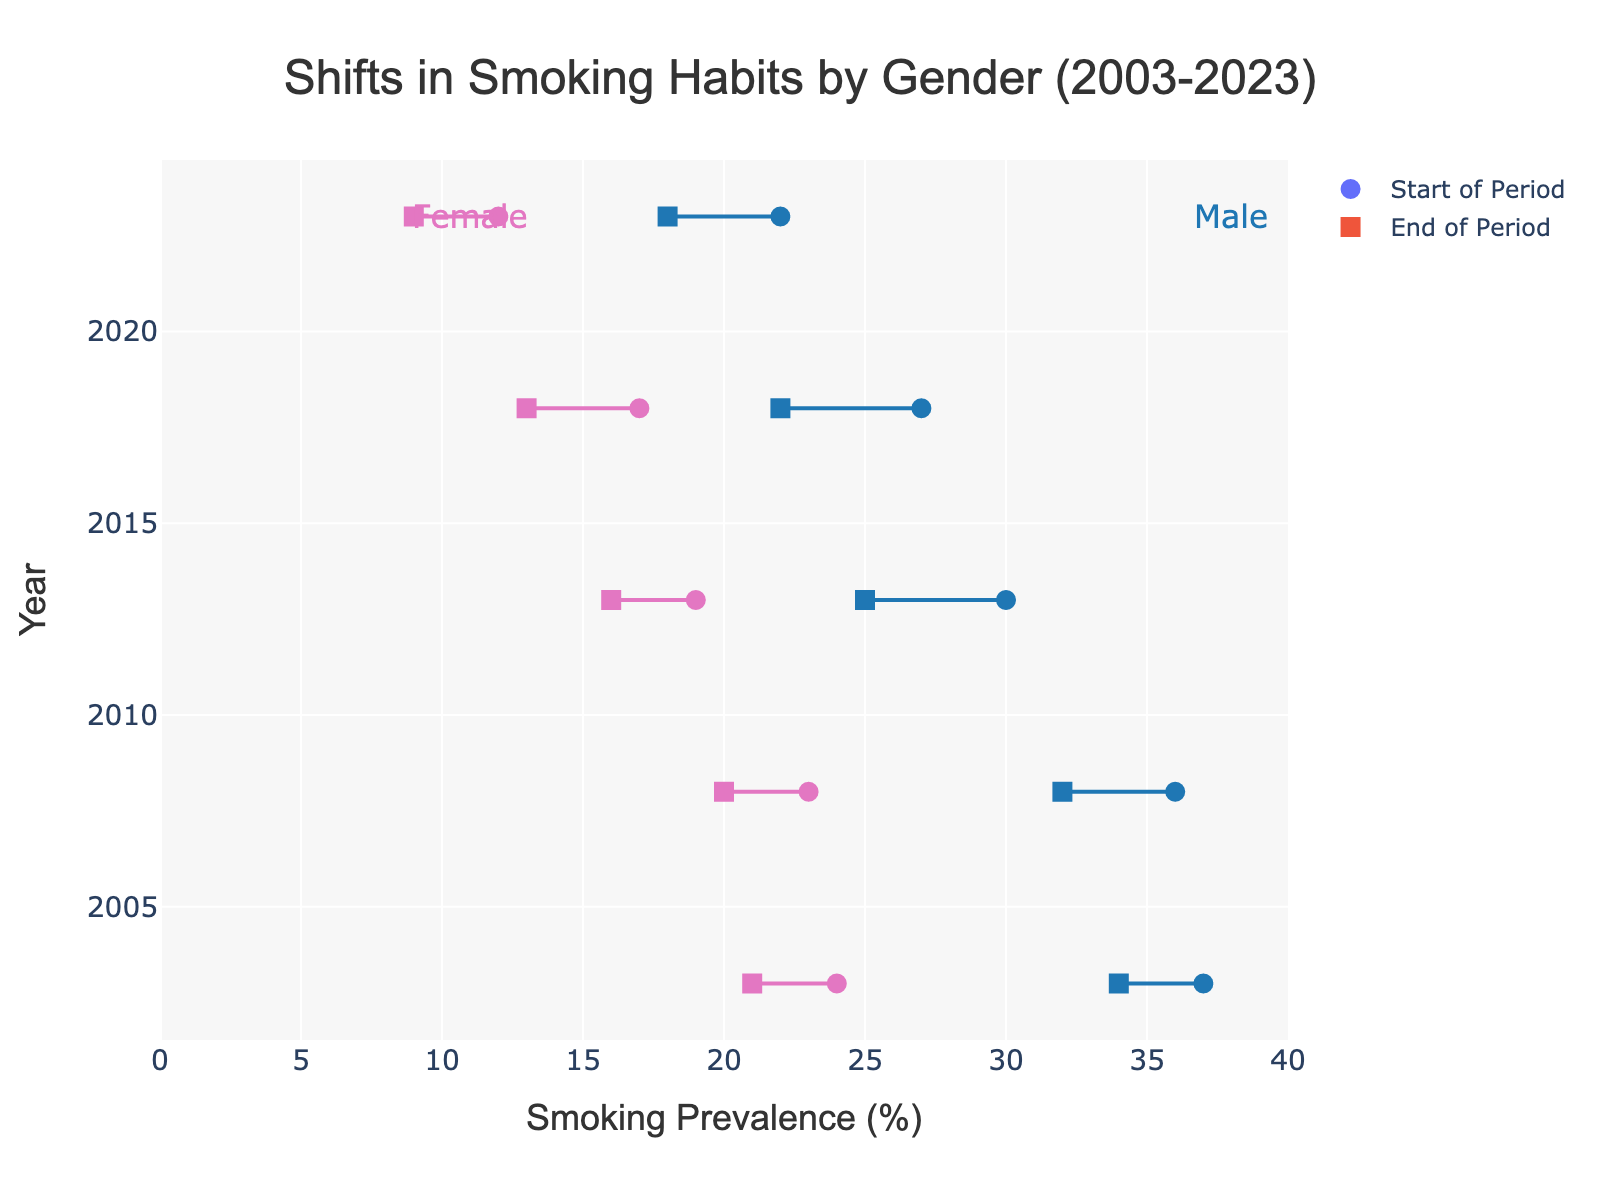What is the overall trend in smoking prevalence for males from 2003 to 2023? Observing the figure, we see that smoking prevalence for males drops consistently from 37% in 2003 to 18% in 2023. This shows a downward trend over the 20-year period.
Answer: Downward trend What happened to the smoking prevalence among females from 2003 to 2023? Similar to males, the figure indicates a consistent decline in smoking prevalence among females. The rate decreases from 24% in 2003 to 9% in 2023.
Answer: Decreased Which gender had a higher smoking prevalence at the start of the period in 2003? The smoking prevalence for males in 2003 was 37%, while for females, it was 24%. Therefore, males had a higher smoking prevalence in 2003.
Answer: Male In which year was the smoking prevalence gap between males and females the smallest? To find the smallest gap, we compare the difference between male and female prevalences for each year: 2003 (13%), 2008 (13%), 2013 (9%), 2018 (9%), and 2023 (9%). The gap is smallest in 2013, 2018, and 2023, all at 9%.
Answer: 2013, 2018, 2023 How much did the smoking prevalence for males decrease from 2003 to 2023? The smoking prevalence for males decreased from 37% in 2003 to 18% in 2023. Subtracting these gives the total decrease: 37% - 18% = 19%.
Answer: 19% How does the change in smoking prevalence from start to end for females in 2018 compare to that for males in the same year? For 2018, the smoking prevalence for females decreased from 17% to 13%, a change of 4%. For males, it decreased from 27% to 22%, a change of 5%. So, the change for males was slightly higher.
Answer: Males had a higher change What is the pattern in the difference in smoking prevalence for females between the start and end of each period? The absolute differences in smoking prevalence for females are: 2003 (3%), 2008 (3%), 2013 (3%), 2018 (4%), 2023 (3%). Most periods show a consistent decrease of 3% except for 2018, which shows a 4% decrease.
Answer: Consistent 3% decrease, except 2018 (4%) What was the smoking prevalence for females in 2013 at the end of the period? Referring to the figure, the smoking prevalence for females in 2013 at the end of the period was 16%.
Answer: 16% Which year had the lowest starting smoking prevalence for males? Observing the figure, the starting prevalence for males is: 2003 (37%), 2008 (36%), 2013 (30%), 2018 (27%), 2023 (22%). The lowest starting prevalence is in 2023, at 22%.
Answer: 2023 How did the smoking prevalence for males in 2008 compare to females in 2008 at the end of the period? For 2008, the smoking prevalence at the end was 32% for males and 20% for females. Males had a higher prevalence than females at the end of 2008.
Answer: Males higher than females 